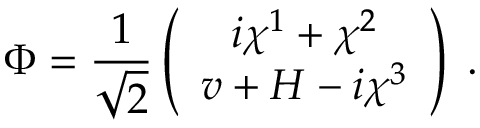<formula> <loc_0><loc_0><loc_500><loc_500>\Phi = \frac { 1 } { \sqrt { 2 } } \left ( \begin{array} { c } { { i \chi ^ { 1 } + \chi ^ { 2 } } } \\ { { v + H - i \chi ^ { 3 } } } \end{array} \right ) \, .</formula> 